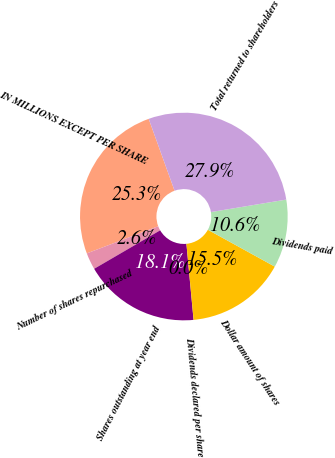Convert chart to OTSL. <chart><loc_0><loc_0><loc_500><loc_500><pie_chart><fcel>IN MILLIONS EXCEPT PER SHARE<fcel>Number of shares repurchased<fcel>Shares outstanding at year end<fcel>Dividends declared per share<fcel>Dollar amount of shares<fcel>Dividends paid<fcel>Total returned to shareholders<nl><fcel>25.28%<fcel>2.62%<fcel>18.09%<fcel>0.01%<fcel>15.49%<fcel>10.62%<fcel>27.89%<nl></chart> 